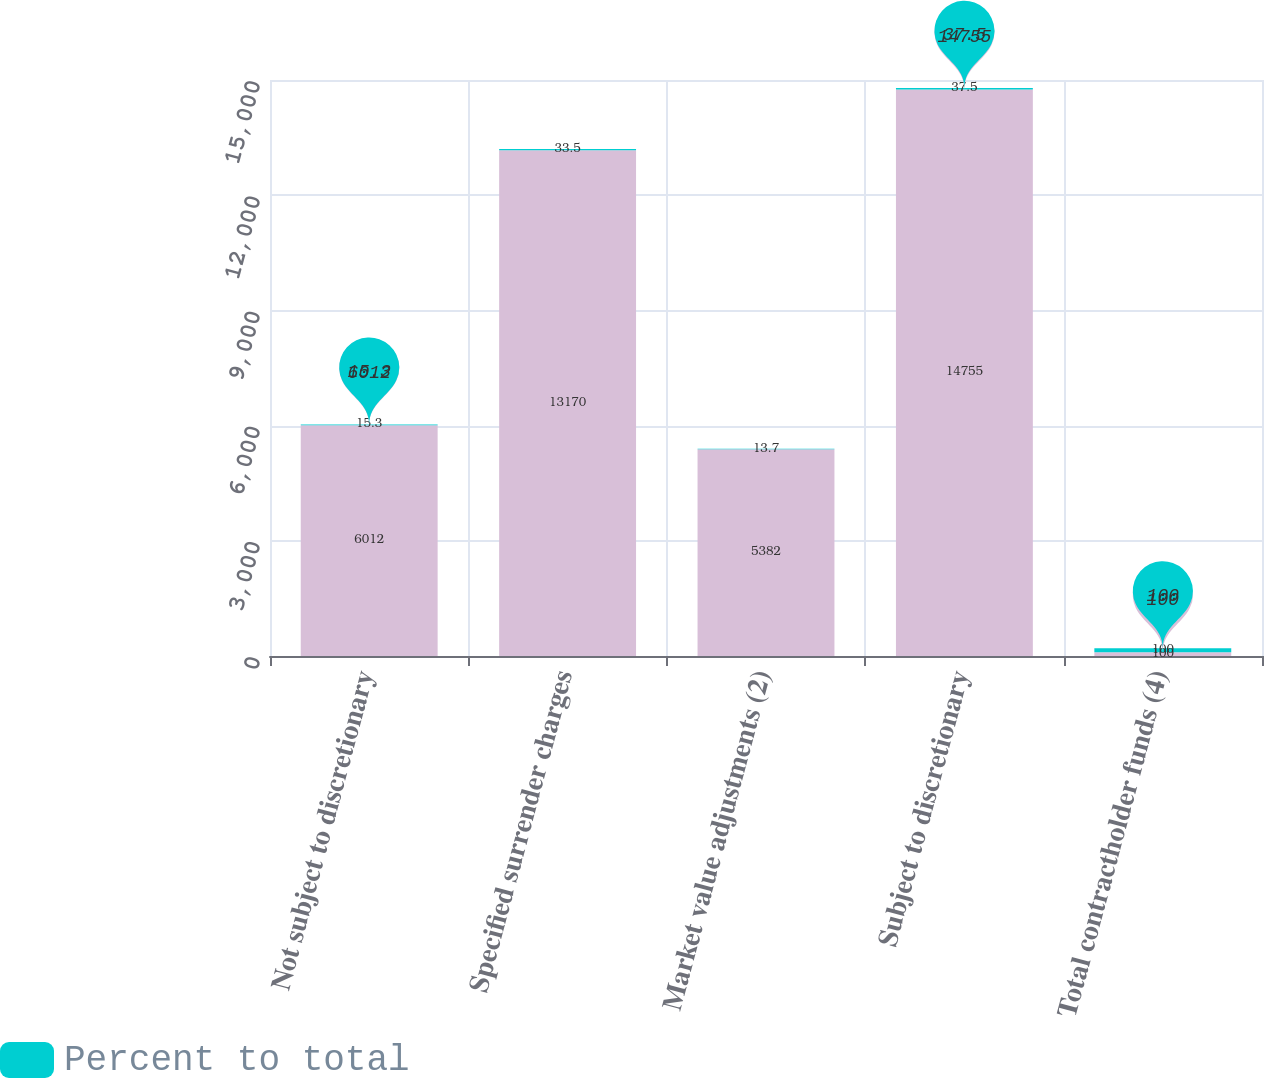<chart> <loc_0><loc_0><loc_500><loc_500><stacked_bar_chart><ecel><fcel>Not subject to discretionary<fcel>Specified surrender charges<fcel>Market value adjustments (2)<fcel>Subject to discretionary<fcel>Total contractholder funds (4)<nl><fcel>nan<fcel>6012<fcel>13170<fcel>5382<fcel>14755<fcel>100<nl><fcel>Percent to total<fcel>15.3<fcel>33.5<fcel>13.7<fcel>37.5<fcel>100<nl></chart> 